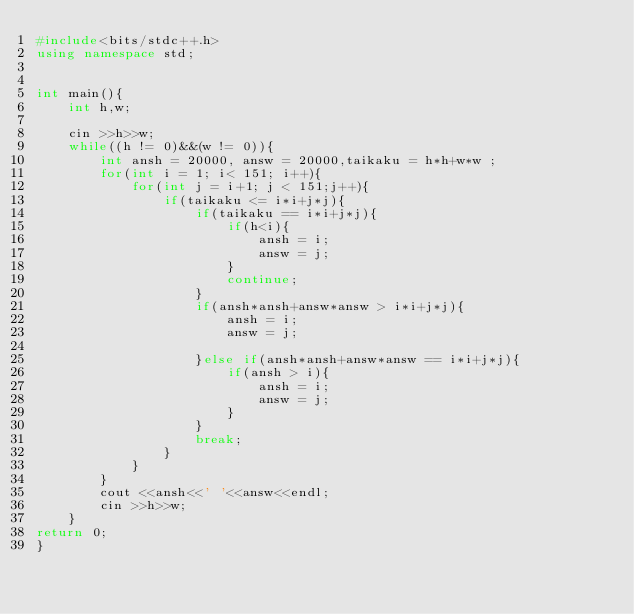Convert code to text. <code><loc_0><loc_0><loc_500><loc_500><_C++_>#include<bits/stdc++.h>
using namespace std;
 
 
int main(){
    int h,w;
 
    cin >>h>>w;
    while((h != 0)&&(w != 0)){
        int ansh = 20000, answ = 20000,taikaku = h*h+w*w ;
        for(int i = 1; i< 151; i++){
            for(int j = i+1; j < 151;j++){
                if(taikaku <= i*i+j*j){
                    if(taikaku == i*i+j*j){
                        if(h<i){
                            ansh = i;
                            answ = j;
                        }
                        continue;
                    }
                    if(ansh*ansh+answ*answ > i*i+j*j){
                        ansh = i;
                        answ = j;
 
                    }else if(ansh*ansh+answ*answ == i*i+j*j){
                        if(ansh > i){
                            ansh = i;
                            answ = j;
                        }
                    }
                    break;
                }
            }
        }
        cout <<ansh<<' '<<answ<<endl;
        cin >>h>>w;
    }
return 0;
}
</code> 